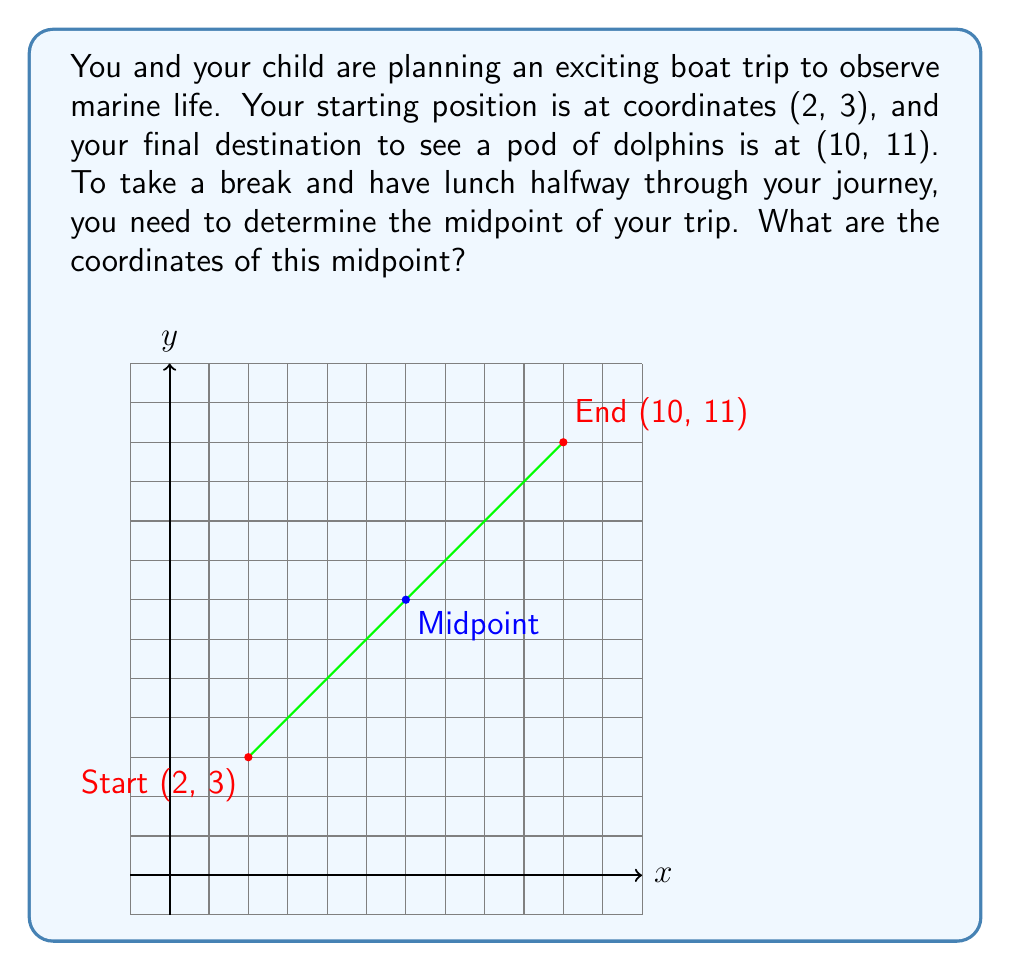Teach me how to tackle this problem. To find the midpoint between two points, we use the midpoint formula:

$$ \text{Midpoint} = \left(\frac{x_1 + x_2}{2}, \frac{y_1 + y_2}{2}\right) $$

Where $(x_1, y_1)$ is the starting point and $(x_2, y_2)$ is the ending point.

Given:
- Starting point: $(2, 3)$
- Ending point: $(10, 11)$

Let's calculate the x-coordinate of the midpoint:
$$ x = \frac{x_1 + x_2}{2} = \frac{2 + 10}{2} = \frac{12}{2} = 6 $$

Now, let's calculate the y-coordinate of the midpoint:
$$ y = \frac{y_1 + y_2}{2} = \frac{3 + 11}{2} = \frac{14}{2} = 7 $$

Therefore, the midpoint coordinates are $(6, 7)$.
Answer: $(6, 7)$ 